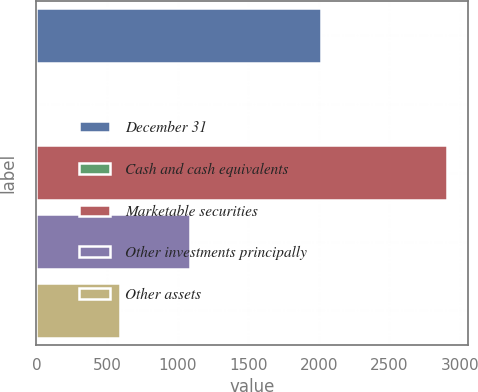Convert chart. <chart><loc_0><loc_0><loc_500><loc_500><bar_chart><fcel>December 31<fcel>Cash and cash equivalents<fcel>Marketable securities<fcel>Other investments principally<fcel>Other assets<nl><fcel>2012<fcel>9<fcel>2908<fcel>1087<fcel>589<nl></chart> 